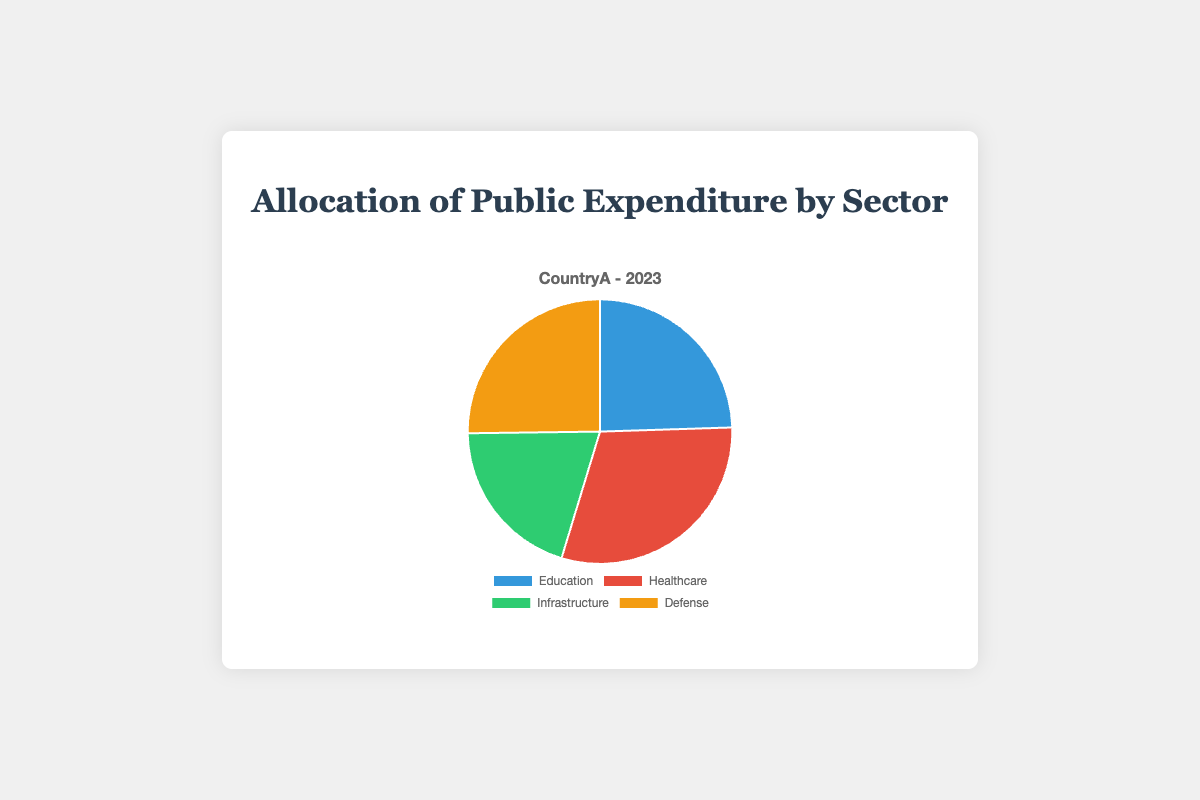What percentage of public expenditure is allocated to Education? According to the pie chart, the sector labeled 'Education' shows a percentage of 24.5%.
Answer: 24.5% Which sector receives the highest share of public expenditure? By examining the pie chart, we see that the Healthcare sector has the largest percentage, which is 30.2%.
Answer: Healthcare How much more funding does Healthcare receive compared to Education? The percentage for Healthcare (30.2%) minus the percentage for Education (24.5%) gives the difference. So, 30.2% - 24.5% = 5.7%.
Answer: 5.7% What are the two sectors with the closest expenditure allocations? By looking at the percentages, Education has 24.5% and Defense has 25.2%. The difference between these two is quite minimal, only 0.7%.
Answer: Education and Defense How does the expenditure on Infrastructure compare to Defense? The percentage for Infrastructure is 20.1% and for Defense is 25.2%. 25.2% is higher than 20.1%, indicating Defense receives more expenditure than Infrastructure.
Answer: Defense Which sector has the smallest allocation and what is its percentage? The pie chart shows that Infrastructure has the smallest allocation with 20.1%.
Answer: Infrastructure, 20.1% What is the total percentage of expenditure devoted to Education and Infrastructure combined? By adding the percentages for Education (24.5%) and Infrastructure (20.1%), we get a combined total of 44.6%.
Answer: 44.6% What’s the difference in expenditure between the two largest sectors, Healthcare and Defense? Healthcare has an allocation of 30.2% while Defense has 25.2%. The difference is found by subtracting 25.2% from 30.2%, resulting in 5%.
Answer: 5% Looking at the color representation, which sector is represented in green? Observing the chart, the sector represented in green is Infrastructure.
Answer: Infrastructure If the government decides to cut 5% from Defense and allocate it to Healthcare, what would the new percentages be for both sectors? Starting from the current values, Defense would decrease to 25.2% - 5% = 20.2%, and Healthcare would increase to 30.2% + 5% = 35.2%.
Answer: Defense: 20.2%, Healthcare: 35.2% 